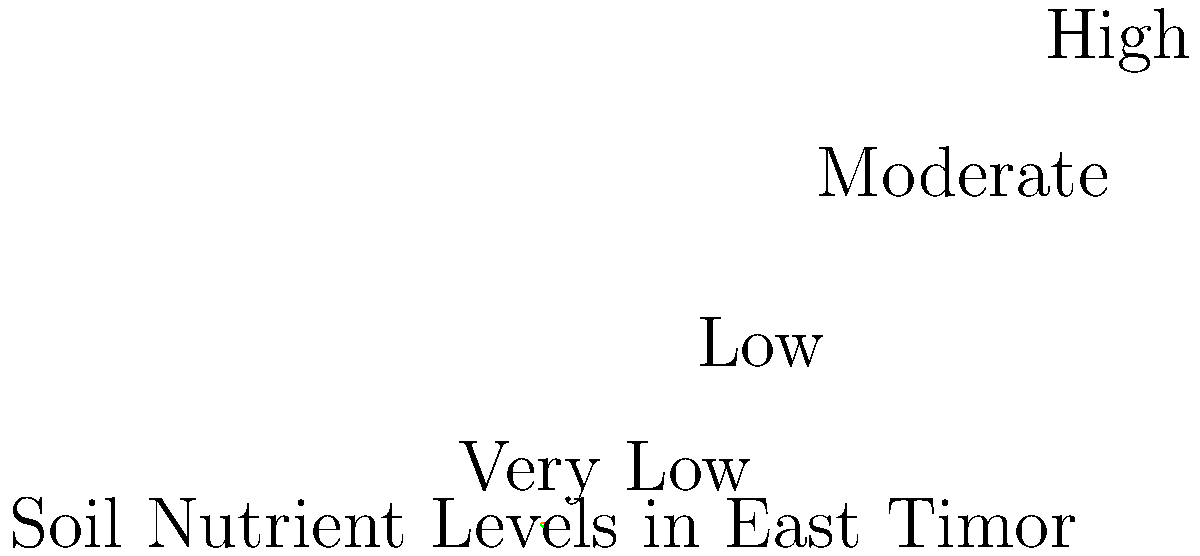Based on the color-coded map of soil nutrient levels in East Timor, which nutrient status is most prevalent, and how might this impact agricultural development strategies for the region? To answer this question, we need to analyze the color-coded map and interpret its implications for agricultural development:

1. Interpret the map:
   - The map shows four categories of soil nutrient levels: Very Low (red), Low (orange), Moderate (green), and High (blue).
   - Each color represents a proportion of the total area.

2. Identify the most prevalent nutrient status:
   - The largest segment is green, representing "Moderate" nutrient levels.
   - This covers approximately 35% of the area, more than any other category.

3. Consider the impact on agricultural development strategies:
   - With moderate nutrient levels being most common, strategies should focus on:
     a) Maintaining and slightly improving soil fertility in these areas.
     b) Selecting crops that perform well in moderately fertile soils.
     c) Implementing sustainable fertilization practices to prevent nutrient depletion.

4. Address other nutrient levels:
   - A significant portion (about 50%) of the area has low or very low nutrient levels.
   - Strategies for these areas might include:
     a) Intensive soil improvement programs.
     b) Introduction of nitrogen-fixing crops or agroforestry systems.
     c) Targeted fertilizer application to boost productivity.

5. Utilize high nutrient areas:
   - The smallest portion (about 15%) has high nutrient levels.
   - These areas could be used for:
     a) High-value or nutrient-demanding crops.
     b) Seed production or nurseries for other regions.

6. Overall strategy:
   - Develop a diversified approach that addresses the varying nutrient levels across the country.
   - Focus on sustainable practices that maintain and improve soil fertility over time.
   - Educate farmers on proper soil management techniques specific to their local nutrient levels.
Answer: Moderate; necessitates balanced strategies for maintaining fertility, crop selection, and targeted improvement in low-nutrient areas. 